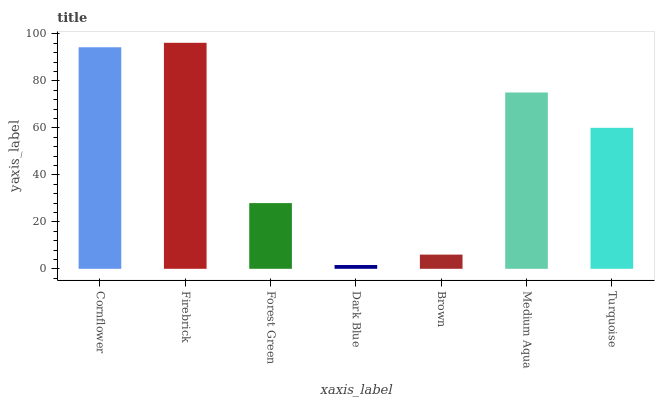Is Dark Blue the minimum?
Answer yes or no. Yes. Is Firebrick the maximum?
Answer yes or no. Yes. Is Forest Green the minimum?
Answer yes or no. No. Is Forest Green the maximum?
Answer yes or no. No. Is Firebrick greater than Forest Green?
Answer yes or no. Yes. Is Forest Green less than Firebrick?
Answer yes or no. Yes. Is Forest Green greater than Firebrick?
Answer yes or no. No. Is Firebrick less than Forest Green?
Answer yes or no. No. Is Turquoise the high median?
Answer yes or no. Yes. Is Turquoise the low median?
Answer yes or no. Yes. Is Brown the high median?
Answer yes or no. No. Is Dark Blue the low median?
Answer yes or no. No. 